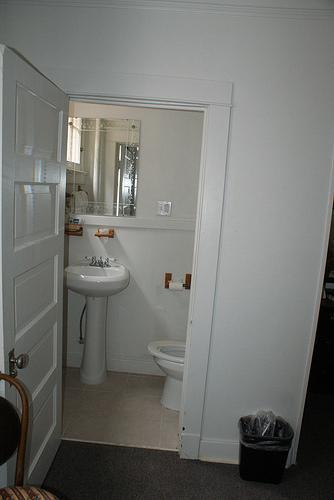How many sinks are there?
Give a very brief answer. 1. 